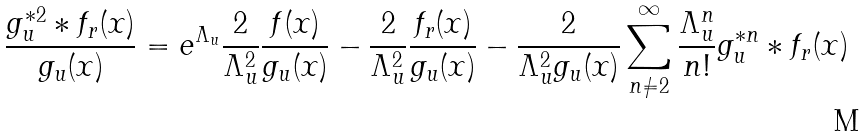Convert formula to latex. <formula><loc_0><loc_0><loc_500><loc_500>\frac { g _ { u } ^ { \ast 2 } \ast f _ { r } ( x ) } { g _ { u } ( x ) } = e ^ { \Lambda _ { u } } \frac { 2 } { \Lambda _ { u } ^ { 2 } } \frac { f ( x ) } { g _ { u } ( x ) } - \frac { 2 } { \Lambda _ { u } ^ { 2 } } \frac { f _ { r } ( x ) } { g _ { u } ( x ) } - \frac { 2 } { \Lambda _ { u } ^ { 2 } g _ { u } ( x ) } \sum _ { n \neq 2 } ^ { \infty } \frac { \Lambda _ { u } ^ { n } } { n ! } g _ { u } ^ { \ast n } \ast f _ { r } ( x )</formula> 